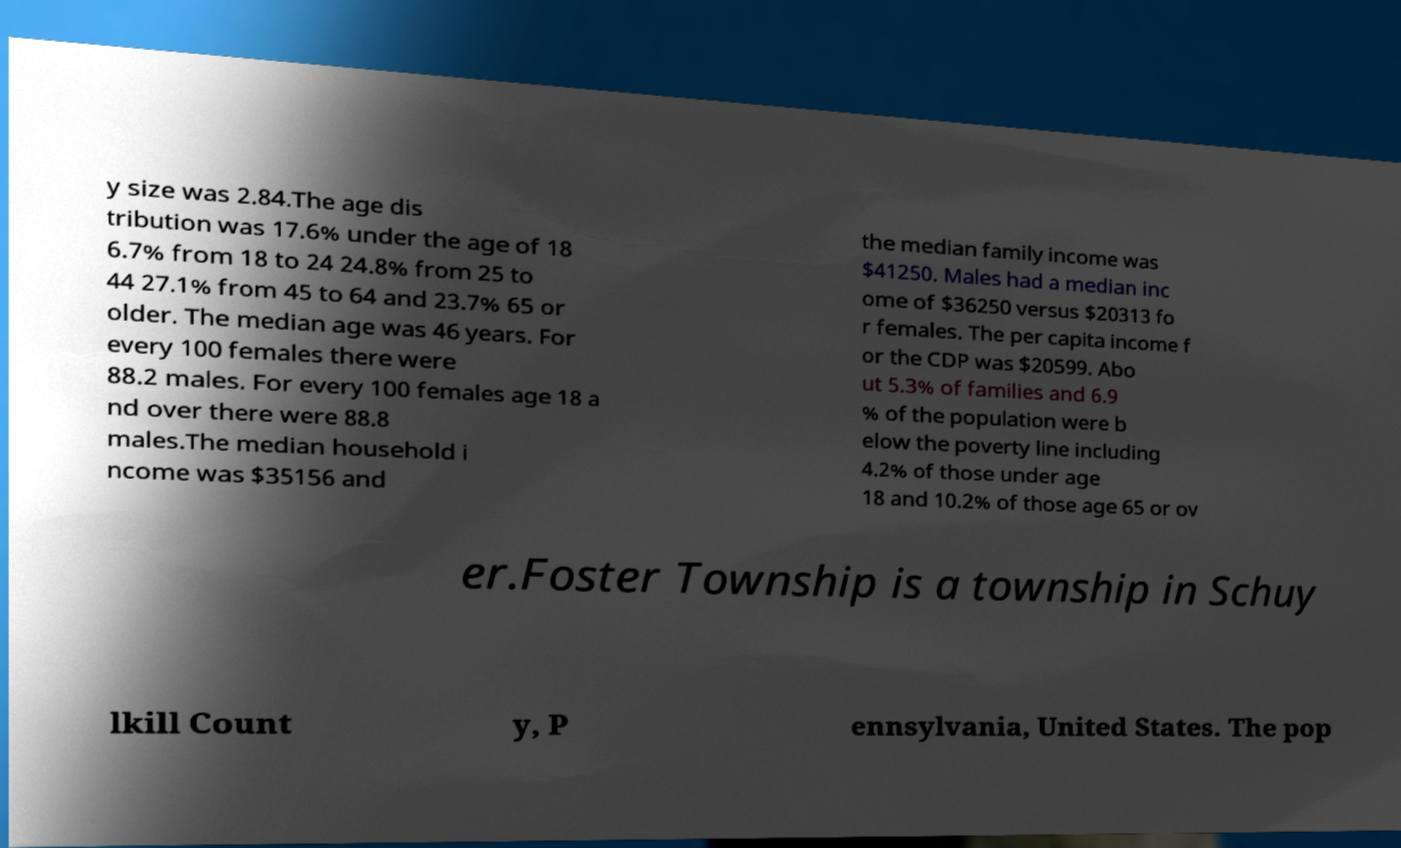Can you accurately transcribe the text from the provided image for me? y size was 2.84.The age dis tribution was 17.6% under the age of 18 6.7% from 18 to 24 24.8% from 25 to 44 27.1% from 45 to 64 and 23.7% 65 or older. The median age was 46 years. For every 100 females there were 88.2 males. For every 100 females age 18 a nd over there were 88.8 males.The median household i ncome was $35156 and the median family income was $41250. Males had a median inc ome of $36250 versus $20313 fo r females. The per capita income f or the CDP was $20599. Abo ut 5.3% of families and 6.9 % of the population were b elow the poverty line including 4.2% of those under age 18 and 10.2% of those age 65 or ov er.Foster Township is a township in Schuy lkill Count y, P ennsylvania, United States. The pop 